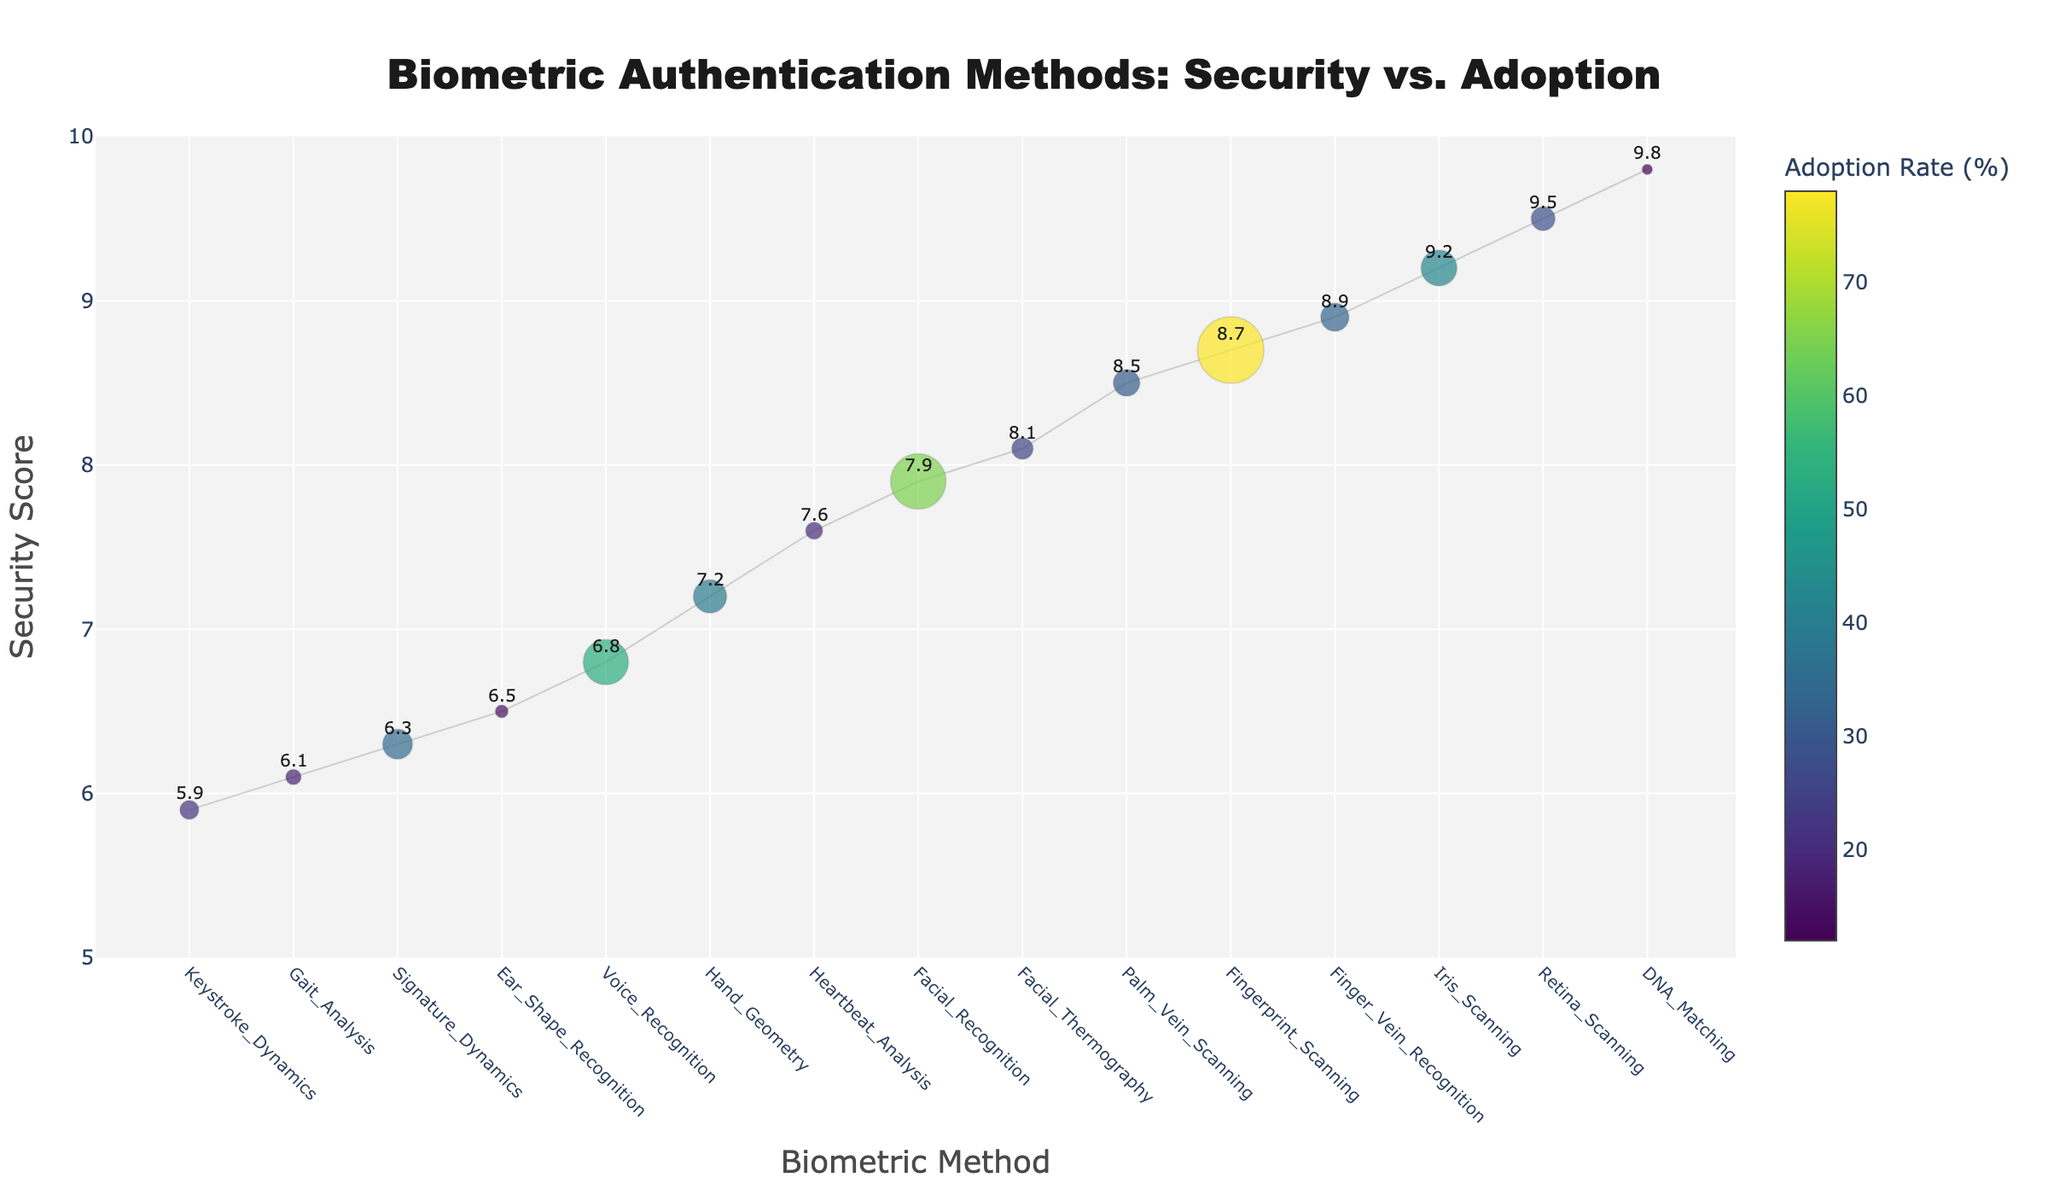What is the title of the plot? The title is located at the top of the plot and reads 'Biometric Authentication Methods: Security vs. Adoption'.
Answer: Biometric Authentication Methods: Security vs. Adoption Which biometric method has the highest security score? Look for the data point with the highest y-position (security score) on the plot.
Answer: DNA Matching What is the adoption rate for retina scanning? Find the dot labeled 'Retina Scanning' and observe its size and the scale on the color bar to determine its adoption rate.
Answer: 28% Which biometric methods have a security score greater than 9? Identify the points that have a y-value greater than 9 and note their labels. These include data points for 'Retina Scanning', 'DNA Matching', and 'Iris Scanning'.
Answer: Retina Scanning, DNA Matching, Iris Scanning Compare the adoption rates of fingerprint scanning and voice recognition. Which one is higher? Observation of the points for 'Fingerprint Scanning' and 'Voice Recognition' will show that the color and size of 'Fingerprint Scanning' indicates a higher adoption rate.
Answer: Fingerprint Scanning What is the average security score of the methods with an adoption rate below 20%? Identify the methods with adoption rates below 20% (Gait Analysis, DNA Matching, Heartbeat Analysis, Ear Shape Recognition, Keystroke Dynamics). Calculate their average security score: (6.1 + 9.8 + 7.6 + 6.5 + 5.9) / 5 = 7.18.
Answer: 7.18 Which biometric method shows the smallest adoption rate while still having a security score above 9? Find the methods with a security score over 9 and compare their adoption rates. 'DNA Matching' has the lowest adoption rate among them.
Answer: DNA Matching How does palm vein scanning compare to fingerprint scanning in terms of security score and adoption rate? Locate both 'Palm Vein Scanning' and 'Fingerprint Scanning' data points. Palm Vein Scanning has a slightly lower security score (8.5 vs. 8.7) and a much lower adoption rate (31% vs. 78%).
Answer: Fingerprint Scanning is higher in both security score and adoption rate What's the median security score of all the biometric methods? Sort all security scores to find the median. The scores are: 5.9, 6.1, 6.3, 6.5, 6.8, 7.2, 7.6, 7.9, 8.1, 8.5, 8.7, 8.9, 9.2, 9.5, 9.8. The median score is the 8th value, which is 7.9.
Answer: 7.9 Which biometric methods have adoption rates between 20% and 40%? Identify the colored points falling within this rate range according to the color bar. The methods are 'Heartbeat Analysis', 'Finger Vein Recognition', 'Signature Dynamics', 'Iris Scanning', and 'Hand Geometry'.
Answer: Heartbeat Analysis, Finger Vein Recognition, Signature Dynamics, Iris Scanning, Hand Geometry 